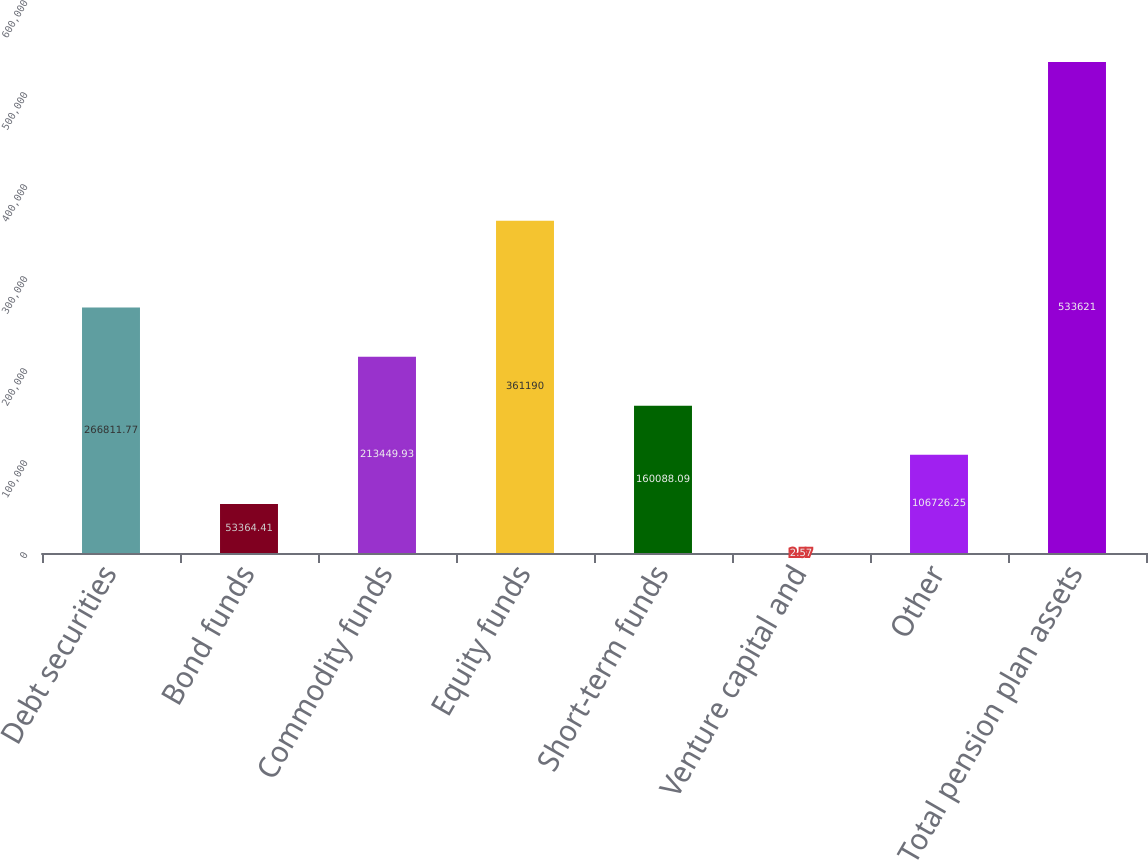<chart> <loc_0><loc_0><loc_500><loc_500><bar_chart><fcel>Debt securities<fcel>Bond funds<fcel>Commodity funds<fcel>Equity funds<fcel>Short-term funds<fcel>Venture capital and<fcel>Other<fcel>Total pension plan assets<nl><fcel>266812<fcel>53364.4<fcel>213450<fcel>361190<fcel>160088<fcel>2.57<fcel>106726<fcel>533621<nl></chart> 